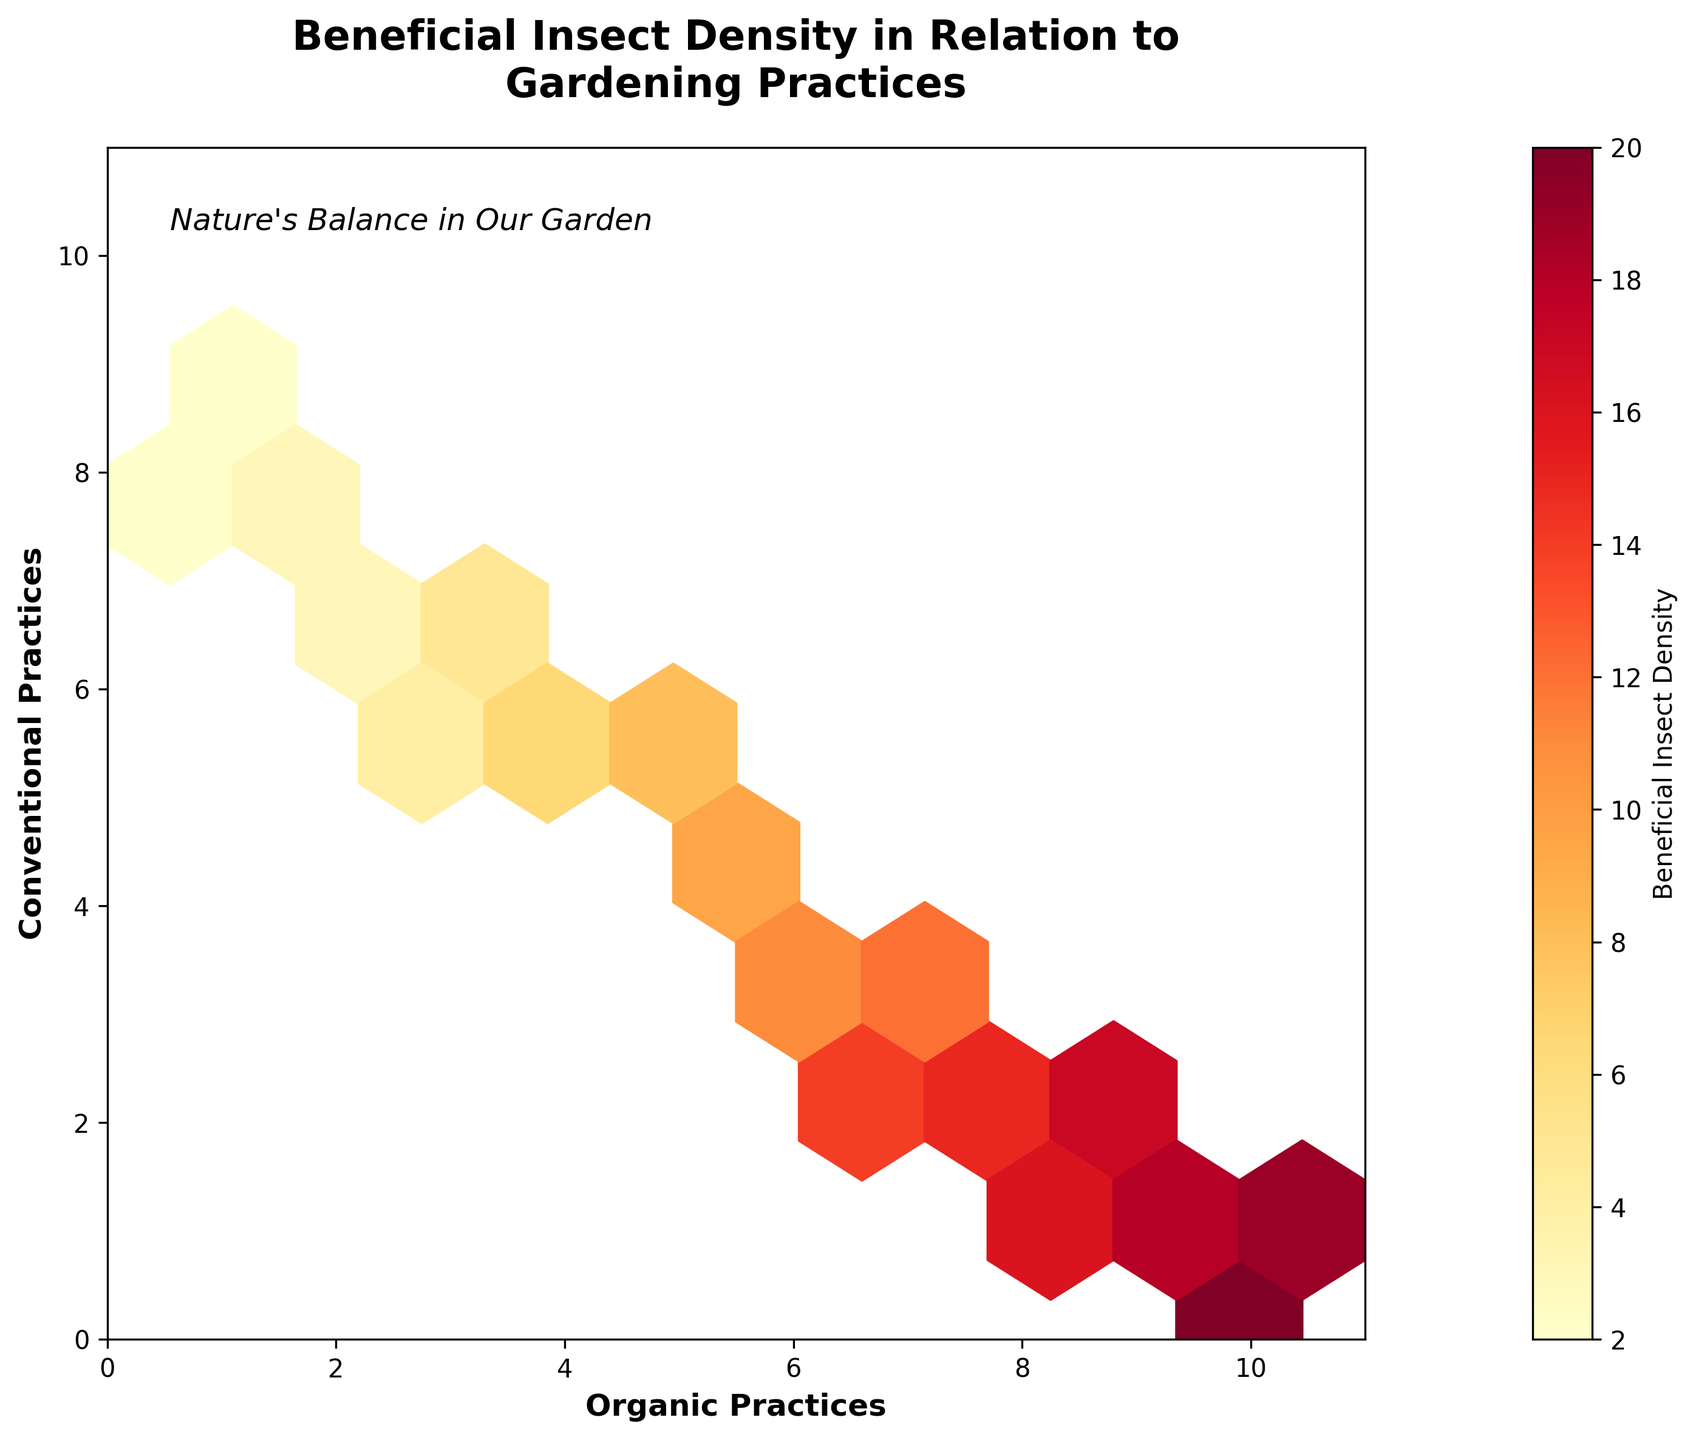What is the title of the plot? The title is typically situated at the top of the plot and describes the main theme of the visualization. In this case, it states the main topic of the relationship between beneficial insect density and gardening practices.
Answer: Beneficial Insect Density in Relation to Gardening Practices What do the x and y axes represent? The labels on the x and y axes indicate the categories being compared. The x-axis represents 'Organic Practices' and the y-axis represents 'Conventional Practices'.
Answer: Organic Practices on the x-axis and Conventional Practices on the y-axis What does the color of the hexagons represent? In a hexbin plot, the color gradient typically represents the intensity or density of a variable. The color bar labeled "Beneficial Insect Density" indicates that darker or brighter hexagons represent higher densities of beneficial insects.
Answer: Density of beneficial insects How does the density of beneficial insects change with an increase in organic practices according to the plot? By observing the plot, we can see that higher organic practice values (closer to 10) correspond to more intensely colored hexagons, indicating higher densities of beneficial insects. Therefore, as organic practices increase, the density of beneficial insects tends to be higher.
Answer: Increases Where are the highest densities of beneficial insects found concerning gardening practices? The highest densities are found where the hexagons are most intensely colored. This occurs toward the higher end of the 'Organic Practices' axis and the lower end of the 'Conventional Practices' axis.
Answer: High organic, low conventional Which value has the highest density of beneficial insects: Organic Practices at 8-10 or Conventional Practices at 8-10? Comparing the colors of hexagons, higher densities are depicted by warmer colors for the values of Organic Practices between 8-10 compared to Conventional Practices between 8-10, which show fewer intensely colored hexagons.
Answer: Organic Practices at 8-10 What is the relationship between beneficial insect density and conventional practices for values 6 and above? For Conventional Practices values of 6 and above, the hexagons tend to be lighter, indicating lower densities of beneficial insects. This pattern suggests a negative relationship.
Answer: Negative relationship How do the beneficial insect densities compare when both organic and conventional practices are balanced (e.g., both at 5)? The hexagon at the intersection of Organic Practices = 5 and Conventional Practices = 5 has a moderate color intensity, showing moderate beneficial insect densities. Compared to areas with high organic practices and low conventional practices, it is relatively lower.
Answer: Moderate density What is the general trend in insect density when conventional practices are low (1 or 2)? Observing the hexagons when Conventional Practices values are at 1 or 2, there are more deeply colored hexagons, indicating a higher density of beneficial insects when conventional practices are low.
Answer: Higher density 